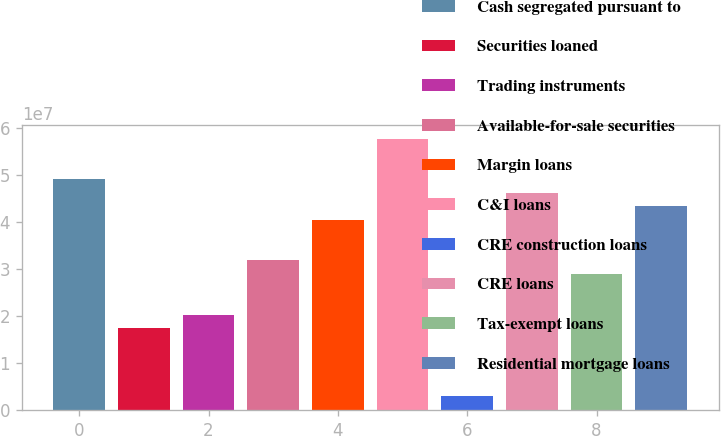Convert chart. <chart><loc_0><loc_0><loc_500><loc_500><bar_chart><fcel>Cash segregated pursuant to<fcel>Securities loaned<fcel>Trading instruments<fcel>Available-for-sale securities<fcel>Margin loans<fcel>C&I loans<fcel>CRE construction loans<fcel>CRE loans<fcel>Tax-exempt loans<fcel>Residential mortgage loans<nl><fcel>4.91085e+07<fcel>1.74039e+07<fcel>2.02861e+07<fcel>3.1815e+07<fcel>4.04618e+07<fcel>5.77552e+07<fcel>2.99266e+06<fcel>4.62262e+07<fcel>2.89328e+07<fcel>4.3344e+07<nl></chart> 